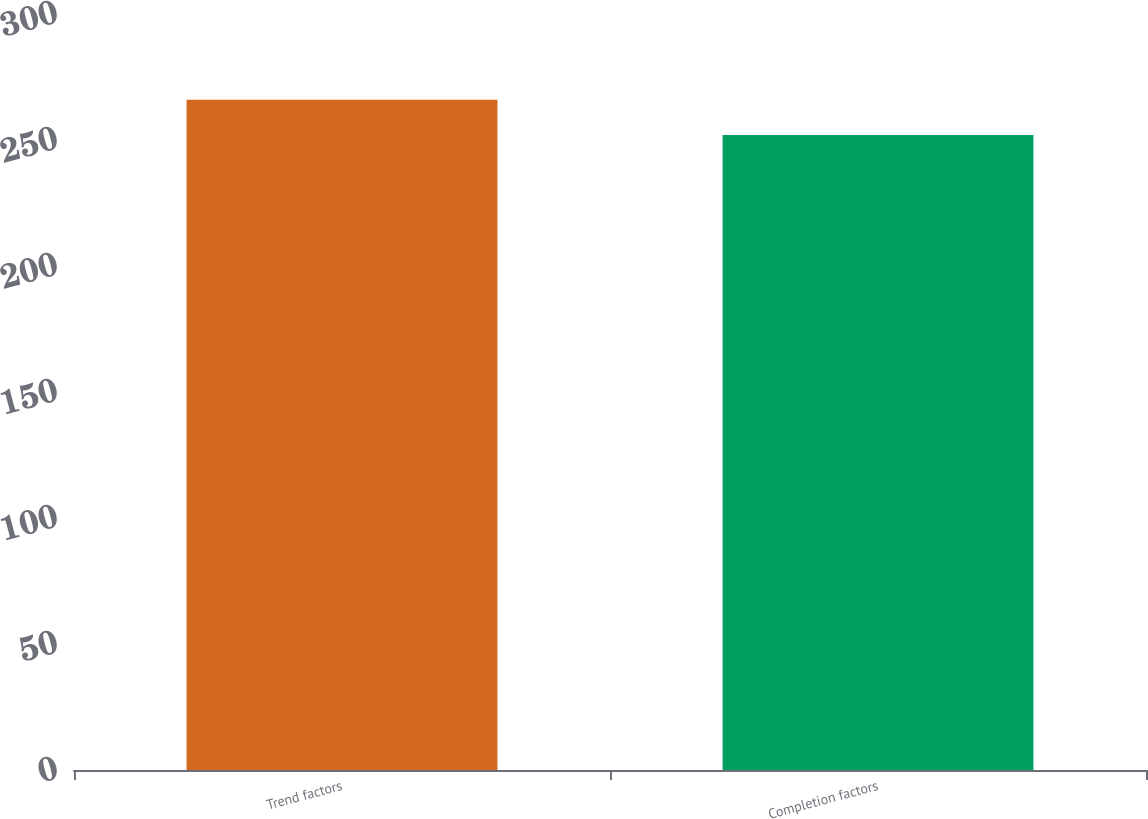<chart> <loc_0><loc_0><loc_500><loc_500><bar_chart><fcel>Trend factors<fcel>Completion factors<nl><fcel>266<fcel>252<nl></chart> 